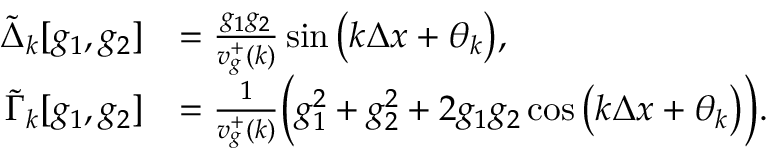<formula> <loc_0><loc_0><loc_500><loc_500>\begin{array} { r l } { \tilde { \Delta } _ { k } [ g _ { 1 } , g _ { 2 } ] } & { = \frac { g _ { 1 } g _ { 2 } } { v _ { g } ^ { + } ( k ) } \sin { \left ( k \Delta x + \theta _ { k } \right ) } , } \\ { \tilde { \Gamma } _ { k } [ g _ { 1 } , g _ { 2 } ] } & { = \frac { 1 } { v _ { g } ^ { + } ( k ) } \left ( g _ { 1 } ^ { 2 } + g _ { 2 } ^ { 2 } + 2 g _ { 1 } g _ { 2 } \cos { \left ( k \Delta x + \theta _ { k } \right ) } \right ) . } \end{array}</formula> 